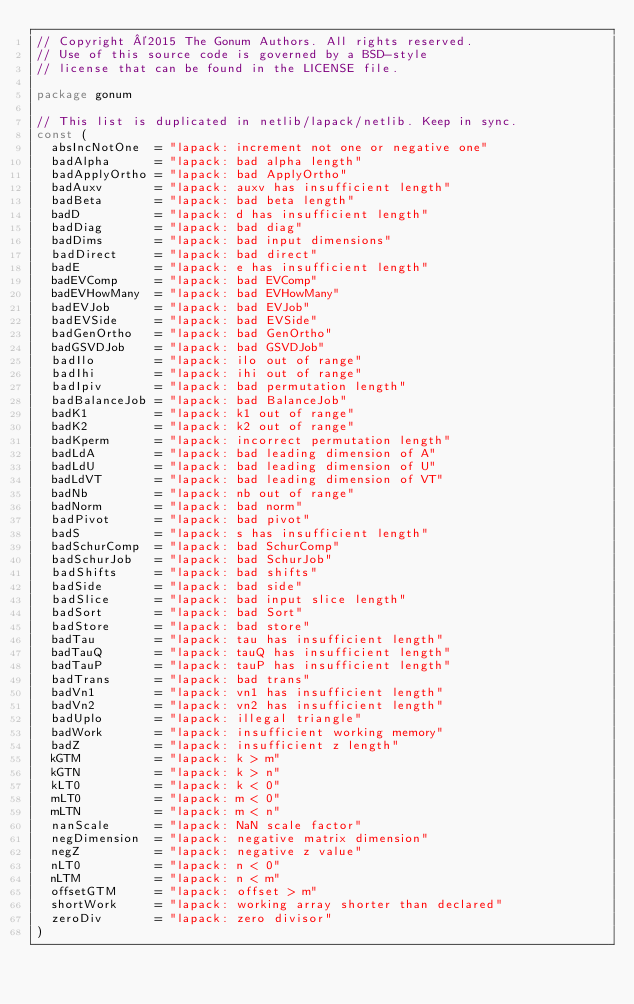Convert code to text. <code><loc_0><loc_0><loc_500><loc_500><_Go_>// Copyright ©2015 The Gonum Authors. All rights reserved.
// Use of this source code is governed by a BSD-style
// license that can be found in the LICENSE file.

package gonum

// This list is duplicated in netlib/lapack/netlib. Keep in sync.
const (
	absIncNotOne  = "lapack: increment not one or negative one"
	badAlpha      = "lapack: bad alpha length"
	badApplyOrtho = "lapack: bad ApplyOrtho"
	badAuxv       = "lapack: auxv has insufficient length"
	badBeta       = "lapack: bad beta length"
	badD          = "lapack: d has insufficient length"
	badDiag       = "lapack: bad diag"
	badDims       = "lapack: bad input dimensions"
	badDirect     = "lapack: bad direct"
	badE          = "lapack: e has insufficient length"
	badEVComp     = "lapack: bad EVComp"
	badEVHowMany  = "lapack: bad EVHowMany"
	badEVJob      = "lapack: bad EVJob"
	badEVSide     = "lapack: bad EVSide"
	badGenOrtho   = "lapack: bad GenOrtho"
	badGSVDJob    = "lapack: bad GSVDJob"
	badIlo        = "lapack: ilo out of range"
	badIhi        = "lapack: ihi out of range"
	badIpiv       = "lapack: bad permutation length"
	badBalanceJob = "lapack: bad BalanceJob"
	badK1         = "lapack: k1 out of range"
	badK2         = "lapack: k2 out of range"
	badKperm      = "lapack: incorrect permutation length"
	badLdA        = "lapack: bad leading dimension of A"
	badLdU        = "lapack: bad leading dimension of U"
	badLdVT       = "lapack: bad leading dimension of VT"
	badNb         = "lapack: nb out of range"
	badNorm       = "lapack: bad norm"
	badPivot      = "lapack: bad pivot"
	badS          = "lapack: s has insufficient length"
	badSchurComp  = "lapack: bad SchurComp"
	badSchurJob   = "lapack: bad SchurJob"
	badShifts     = "lapack: bad shifts"
	badSide       = "lapack: bad side"
	badSlice      = "lapack: bad input slice length"
	badSort       = "lapack: bad Sort"
	badStore      = "lapack: bad store"
	badTau        = "lapack: tau has insufficient length"
	badTauQ       = "lapack: tauQ has insufficient length"
	badTauP       = "lapack: tauP has insufficient length"
	badTrans      = "lapack: bad trans"
	badVn1        = "lapack: vn1 has insufficient length"
	badVn2        = "lapack: vn2 has insufficient length"
	badUplo       = "lapack: illegal triangle"
	badWork       = "lapack: insufficient working memory"
	badZ          = "lapack: insufficient z length"
	kGTM          = "lapack: k > m"
	kGTN          = "lapack: k > n"
	kLT0          = "lapack: k < 0"
	mLT0          = "lapack: m < 0"
	mLTN          = "lapack: m < n"
	nanScale      = "lapack: NaN scale factor"
	negDimension  = "lapack: negative matrix dimension"
	negZ          = "lapack: negative z value"
	nLT0          = "lapack: n < 0"
	nLTM          = "lapack: n < m"
	offsetGTM     = "lapack: offset > m"
	shortWork     = "lapack: working array shorter than declared"
	zeroDiv       = "lapack: zero divisor"
)
</code> 